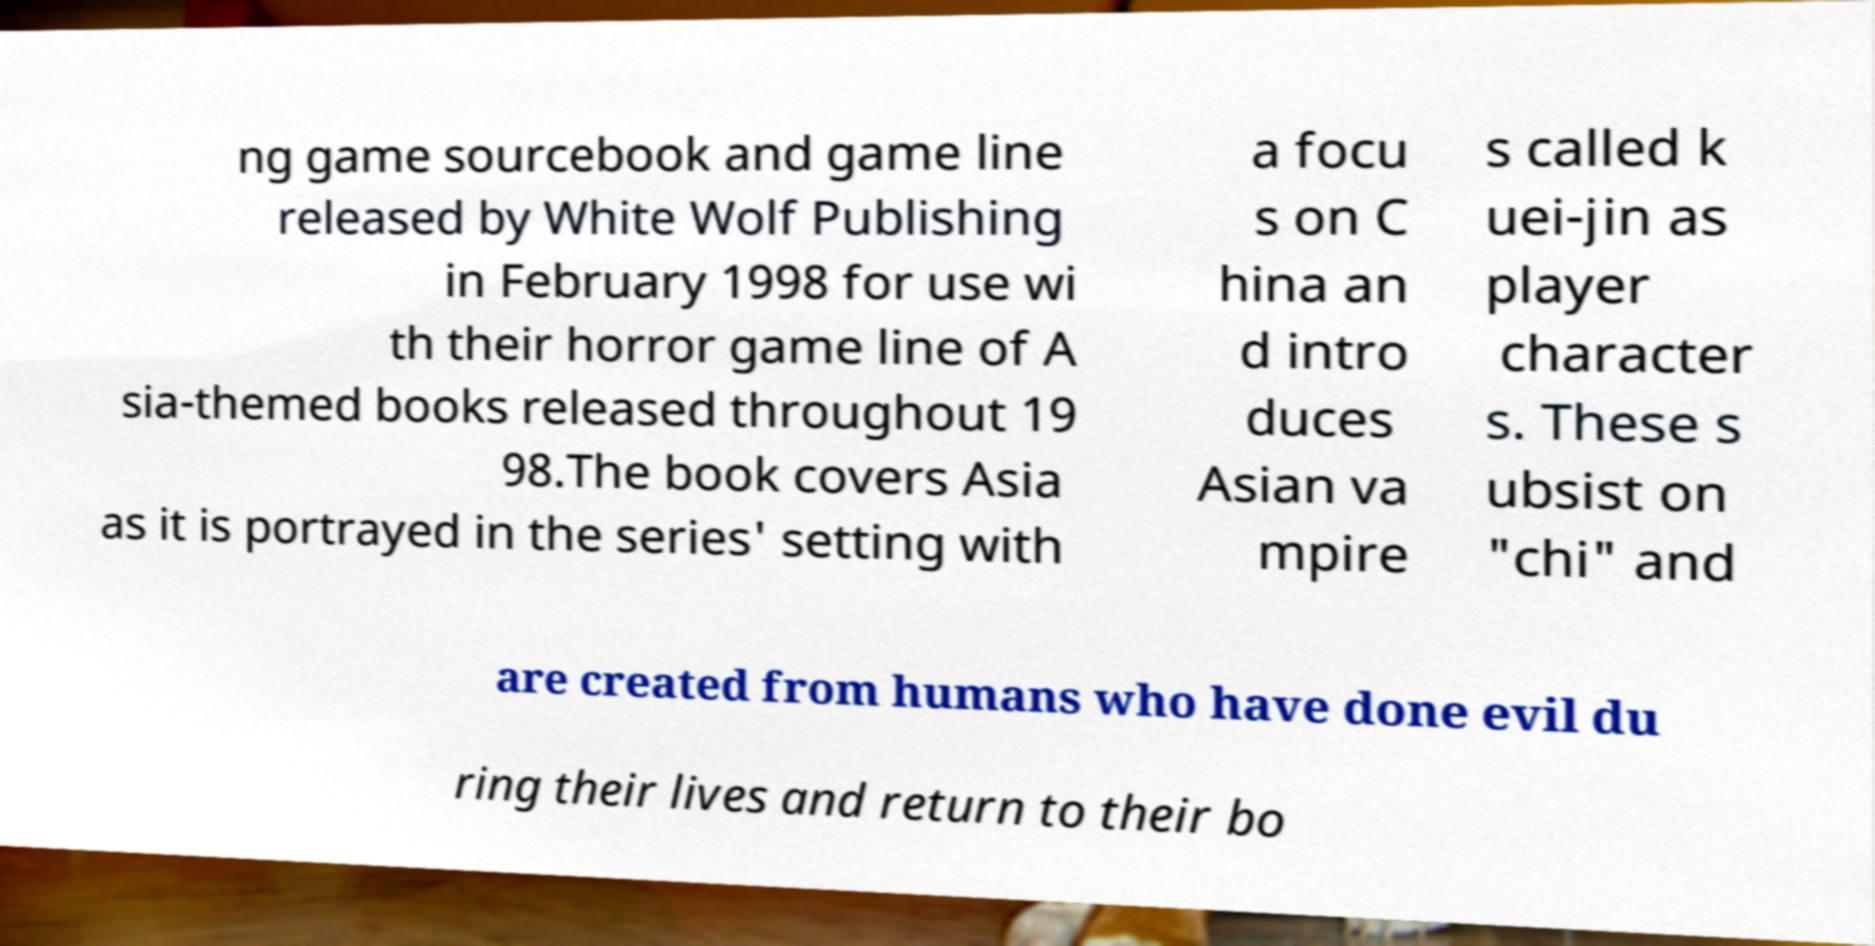For documentation purposes, I need the text within this image transcribed. Could you provide that? ng game sourcebook and game line released by White Wolf Publishing in February 1998 for use wi th their horror game line of A sia-themed books released throughout 19 98.The book covers Asia as it is portrayed in the series' setting with a focu s on C hina an d intro duces Asian va mpire s called k uei-jin as player character s. These s ubsist on "chi" and are created from humans who have done evil du ring their lives and return to their bo 